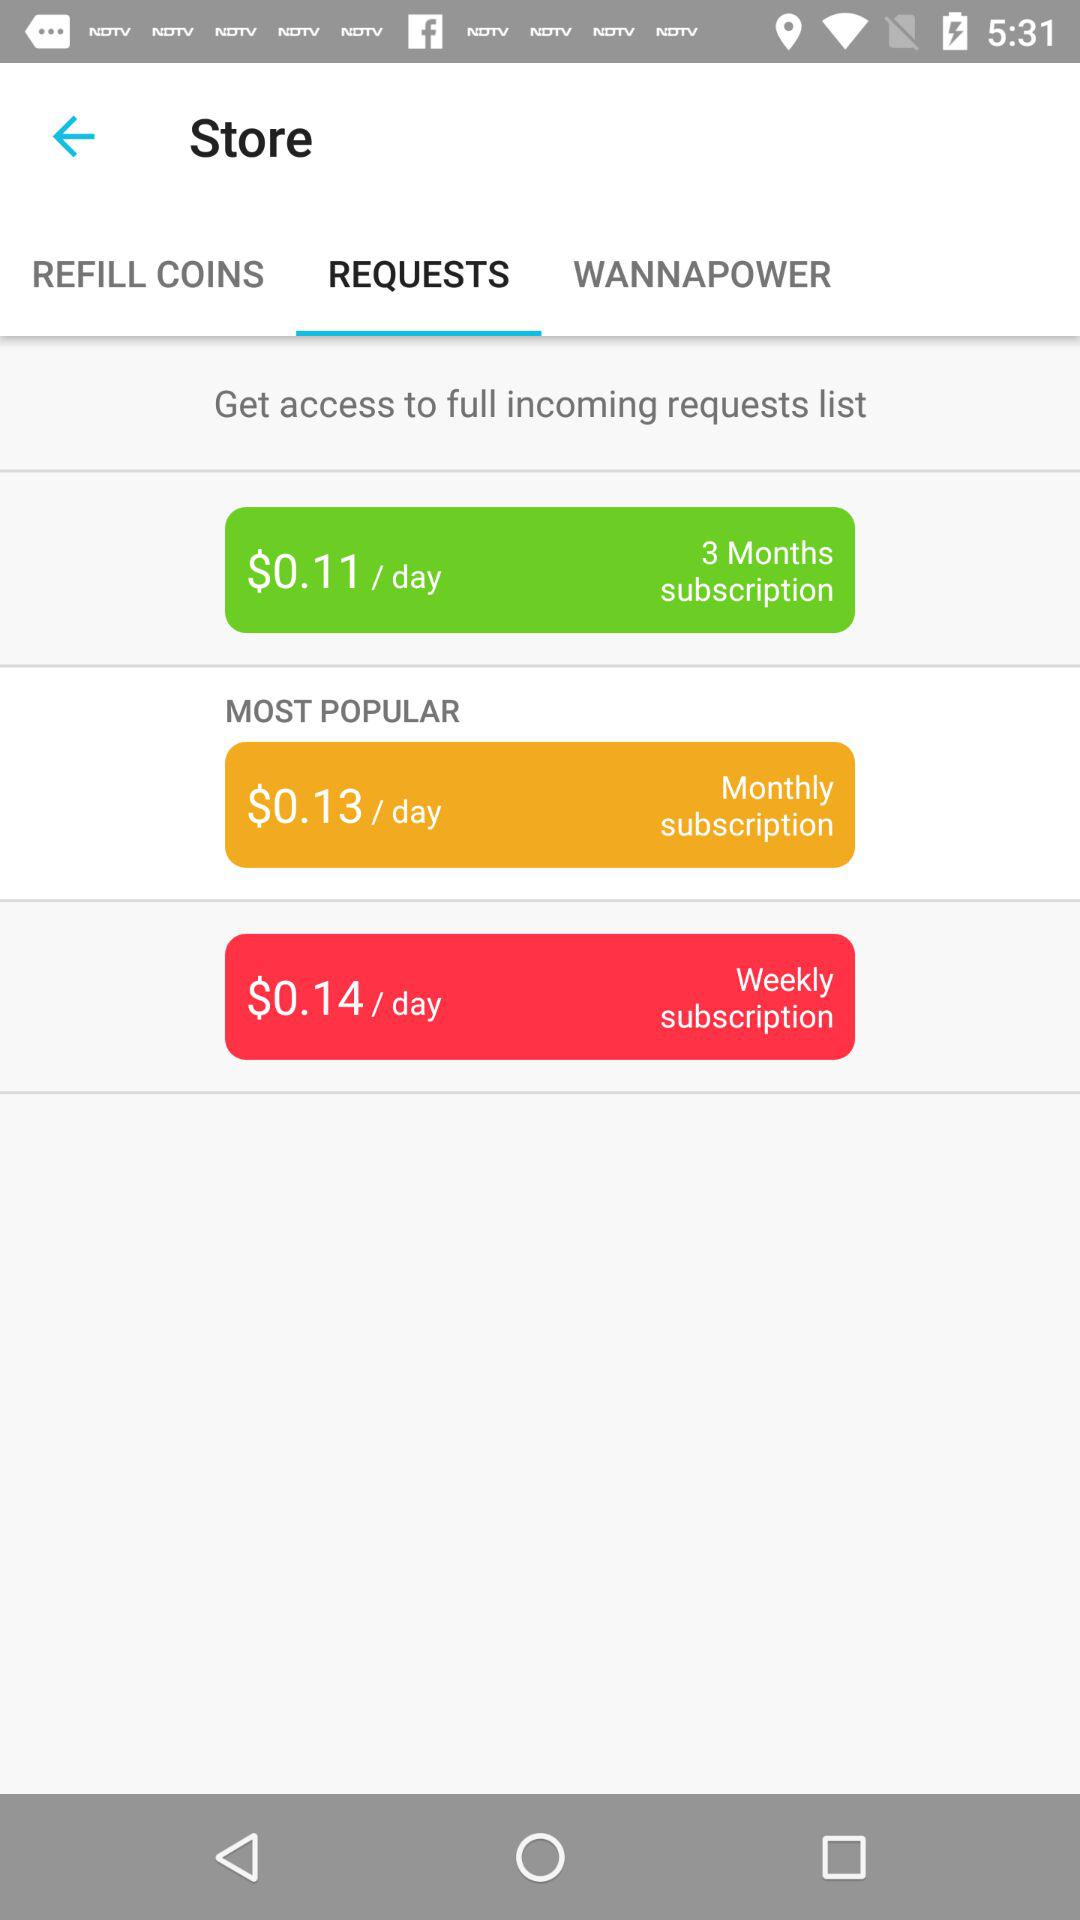How much more does the monthly subscription cost than the weekly subscription?
Answer the question using a single word or phrase. $0.01 